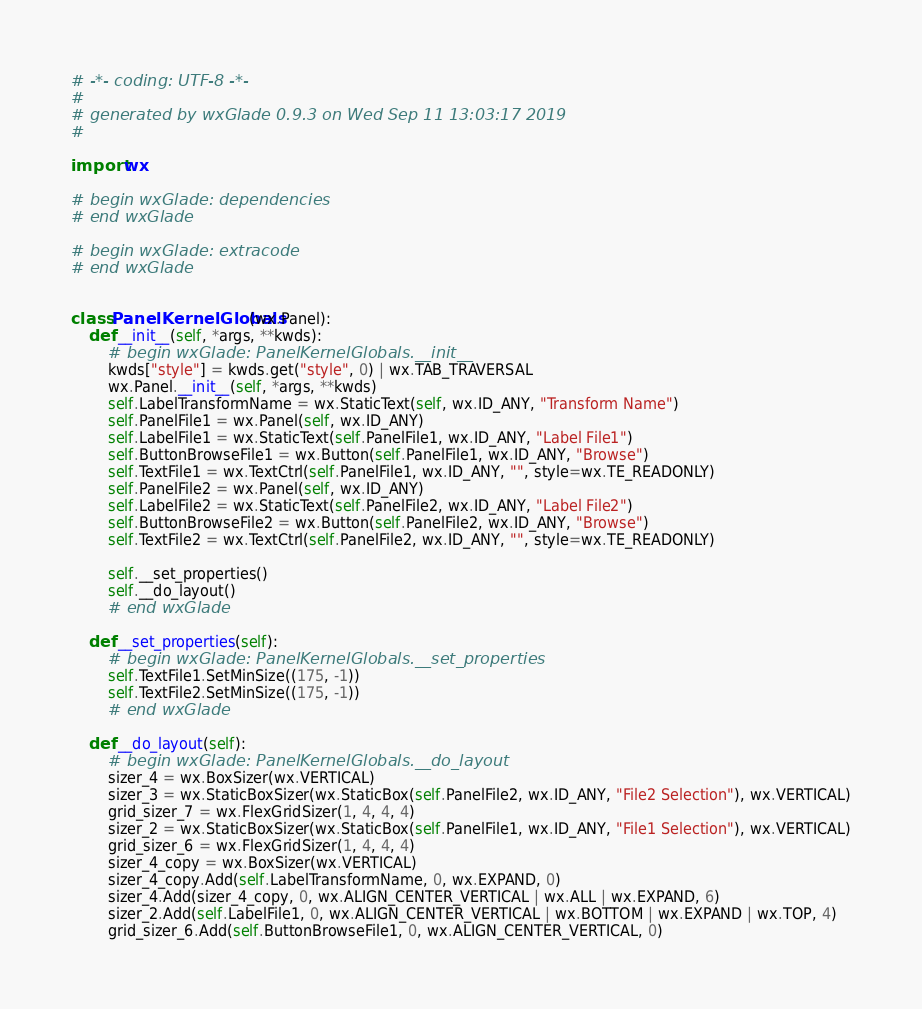<code> <loc_0><loc_0><loc_500><loc_500><_Python_># -*- coding: UTF-8 -*-
#
# generated by wxGlade 0.9.3 on Wed Sep 11 13:03:17 2019
#

import wx

# begin wxGlade: dependencies
# end wxGlade

# begin wxGlade: extracode
# end wxGlade


class PanelKernelGlobals(wx.Panel):
    def __init__(self, *args, **kwds):
        # begin wxGlade: PanelKernelGlobals.__init__
        kwds["style"] = kwds.get("style", 0) | wx.TAB_TRAVERSAL
        wx.Panel.__init__(self, *args, **kwds)
        self.LabelTransformName = wx.StaticText(self, wx.ID_ANY, "Transform Name")
        self.PanelFile1 = wx.Panel(self, wx.ID_ANY)
        self.LabelFile1 = wx.StaticText(self.PanelFile1, wx.ID_ANY, "Label File1")
        self.ButtonBrowseFile1 = wx.Button(self.PanelFile1, wx.ID_ANY, "Browse")
        self.TextFile1 = wx.TextCtrl(self.PanelFile1, wx.ID_ANY, "", style=wx.TE_READONLY)
        self.PanelFile2 = wx.Panel(self, wx.ID_ANY)
        self.LabelFile2 = wx.StaticText(self.PanelFile2, wx.ID_ANY, "Label File2")
        self.ButtonBrowseFile2 = wx.Button(self.PanelFile2, wx.ID_ANY, "Browse")
        self.TextFile2 = wx.TextCtrl(self.PanelFile2, wx.ID_ANY, "", style=wx.TE_READONLY)

        self.__set_properties()
        self.__do_layout()
        # end wxGlade

    def __set_properties(self):
        # begin wxGlade: PanelKernelGlobals.__set_properties
        self.TextFile1.SetMinSize((175, -1))
        self.TextFile2.SetMinSize((175, -1))
        # end wxGlade

    def __do_layout(self):
        # begin wxGlade: PanelKernelGlobals.__do_layout
        sizer_4 = wx.BoxSizer(wx.VERTICAL)
        sizer_3 = wx.StaticBoxSizer(wx.StaticBox(self.PanelFile2, wx.ID_ANY, "File2 Selection"), wx.VERTICAL)
        grid_sizer_7 = wx.FlexGridSizer(1, 4, 4, 4)
        sizer_2 = wx.StaticBoxSizer(wx.StaticBox(self.PanelFile1, wx.ID_ANY, "File1 Selection"), wx.VERTICAL)
        grid_sizer_6 = wx.FlexGridSizer(1, 4, 4, 4)
        sizer_4_copy = wx.BoxSizer(wx.VERTICAL)
        sizer_4_copy.Add(self.LabelTransformName, 0, wx.EXPAND, 0)
        sizer_4.Add(sizer_4_copy, 0, wx.ALIGN_CENTER_VERTICAL | wx.ALL | wx.EXPAND, 6)
        sizer_2.Add(self.LabelFile1, 0, wx.ALIGN_CENTER_VERTICAL | wx.BOTTOM | wx.EXPAND | wx.TOP, 4)
        grid_sizer_6.Add(self.ButtonBrowseFile1, 0, wx.ALIGN_CENTER_VERTICAL, 0)</code> 